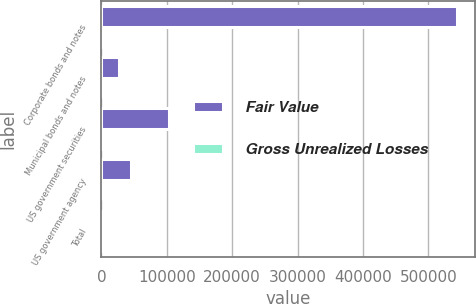Convert chart. <chart><loc_0><loc_0><loc_500><loc_500><stacked_bar_chart><ecel><fcel>Corporate bonds and notes<fcel>Municipal bonds and notes<fcel>US government securities<fcel>US government agency<fcel>Total<nl><fcel>Fair Value<fcel>543729<fcel>26846<fcel>103470<fcel>44812<fcel>2314<nl><fcel>Gross Unrealized Losses<fcel>1800<fcel>123<fcel>281<fcel>110<fcel>2314<nl></chart> 